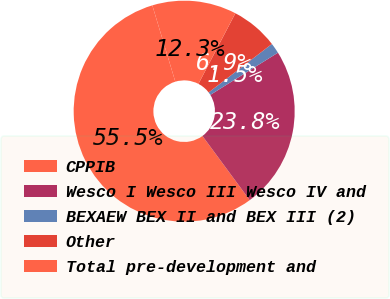Convert chart to OTSL. <chart><loc_0><loc_0><loc_500><loc_500><pie_chart><fcel>CPPIB<fcel>Wesco I Wesco III Wesco IV and<fcel>BEXAEW BEX II and BEX III (2)<fcel>Other<fcel>Total pre-development and<nl><fcel>55.46%<fcel>23.77%<fcel>1.53%<fcel>6.93%<fcel>12.32%<nl></chart> 